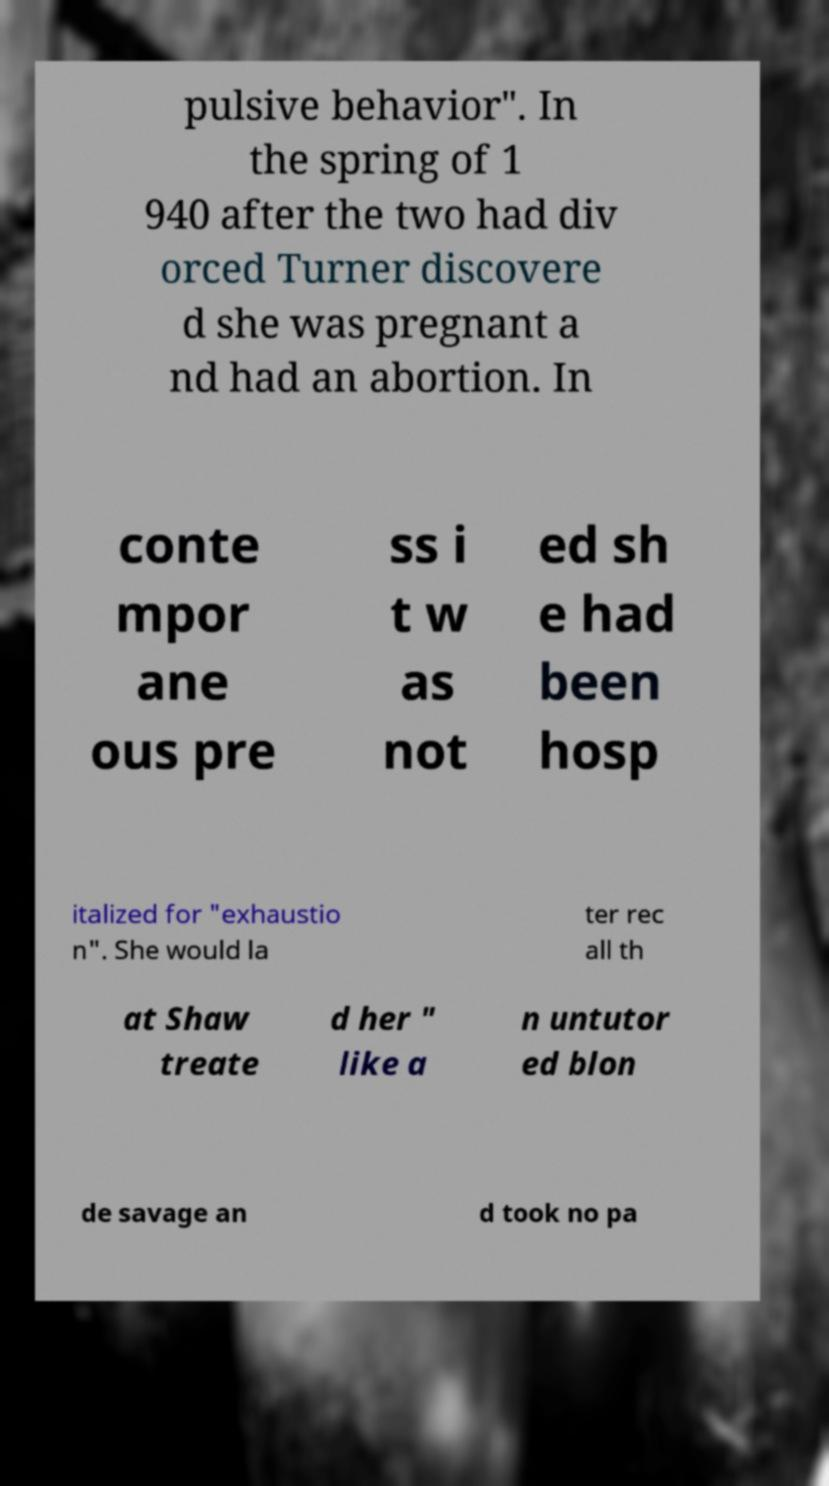Can you read and provide the text displayed in the image?This photo seems to have some interesting text. Can you extract and type it out for me? pulsive behavior". In the spring of 1 940 after the two had div orced Turner discovere d she was pregnant a nd had an abortion. In conte mpor ane ous pre ss i t w as not ed sh e had been hosp italized for "exhaustio n". She would la ter rec all th at Shaw treate d her " like a n untutor ed blon de savage an d took no pa 